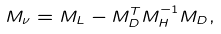Convert formula to latex. <formula><loc_0><loc_0><loc_500><loc_500>M _ { \nu } = M _ { L } - M _ { D } ^ { T } M _ { H } ^ { - 1 } M _ { D } ,</formula> 